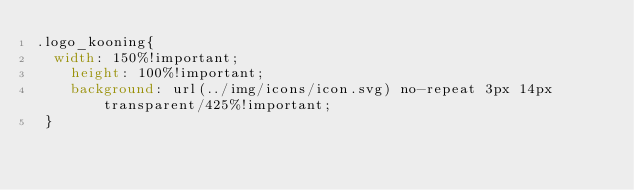<code> <loc_0><loc_0><loc_500><loc_500><_CSS_>.logo_kooning{
 	width: 150%!important;
    height: 100%!important;
    background: url(../img/icons/icon.svg) no-repeat 3px 14px transparent/425%!important;
 }</code> 